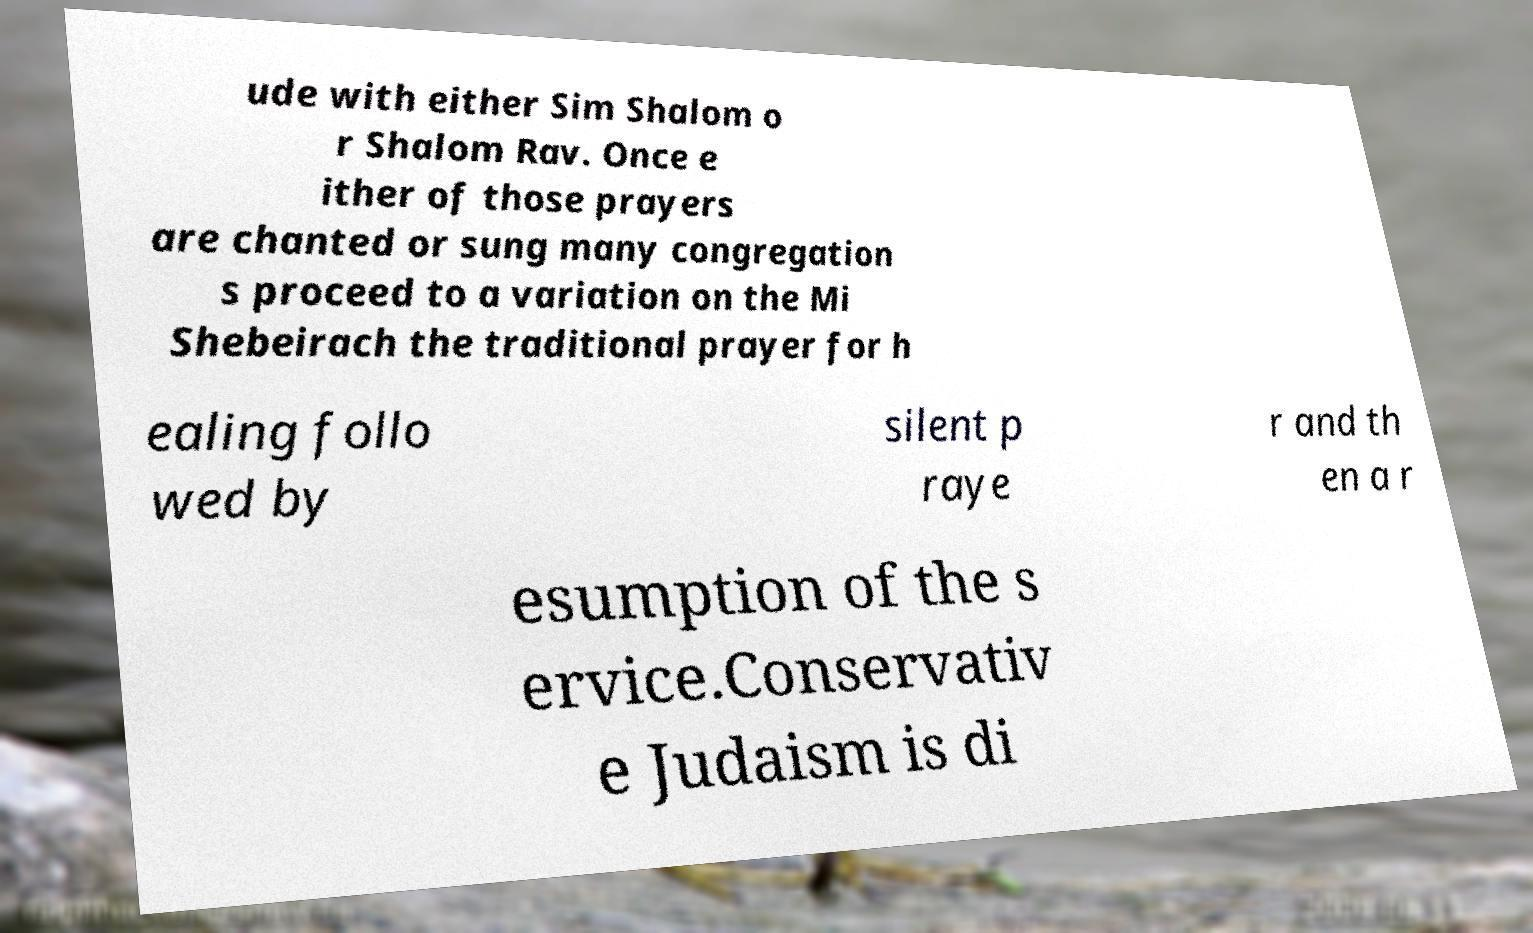Please identify and transcribe the text found in this image. ude with either Sim Shalom o r Shalom Rav. Once e ither of those prayers are chanted or sung many congregation s proceed to a variation on the Mi Shebeirach the traditional prayer for h ealing follo wed by silent p raye r and th en a r esumption of the s ervice.Conservativ e Judaism is di 